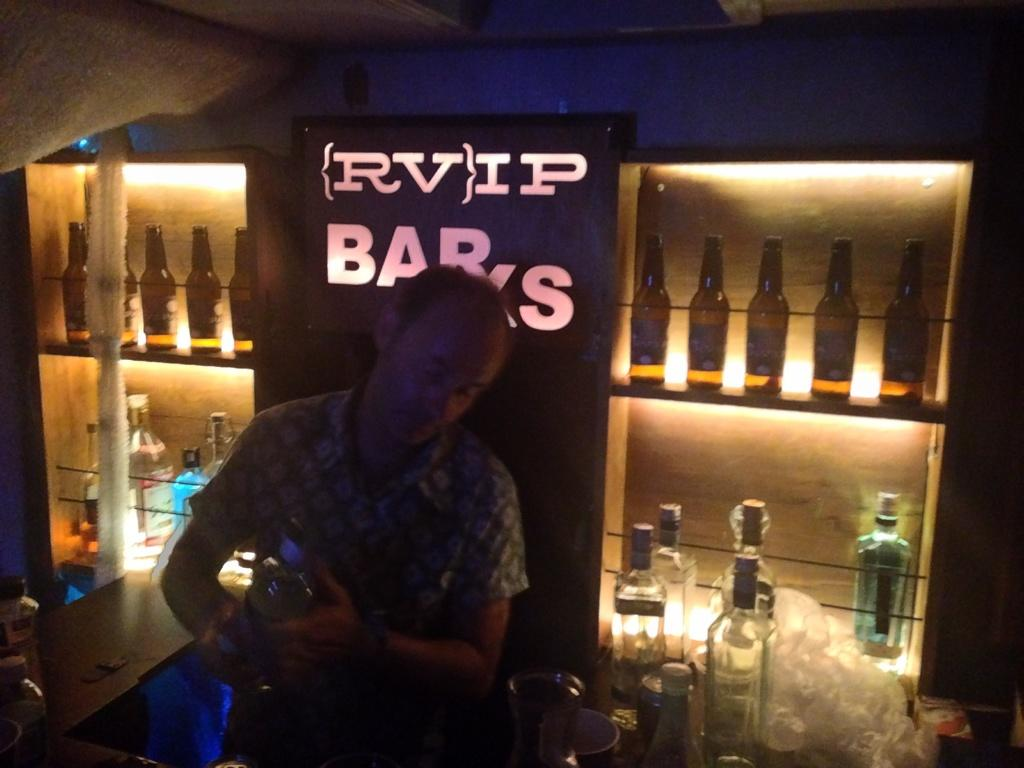What is the man in the image doing? The man is standing in the image and holding a bottle in his hand. How many bottles can be seen in the image? There are bottles visible in the image, including the one the man is holding and the ones in the background. What else can be seen in the image besides the man and the bottles? There are glasses and a plastic cover visible in the image. What is the arrangement of the bottles in the background? In the background, there are bottles in a rack. What type of hammer is the man using to break the horn in the image? There is no hammer or horn present in the image; it only features a man holding a bottle, glasses, a plastic cover, and bottles in a rack. 